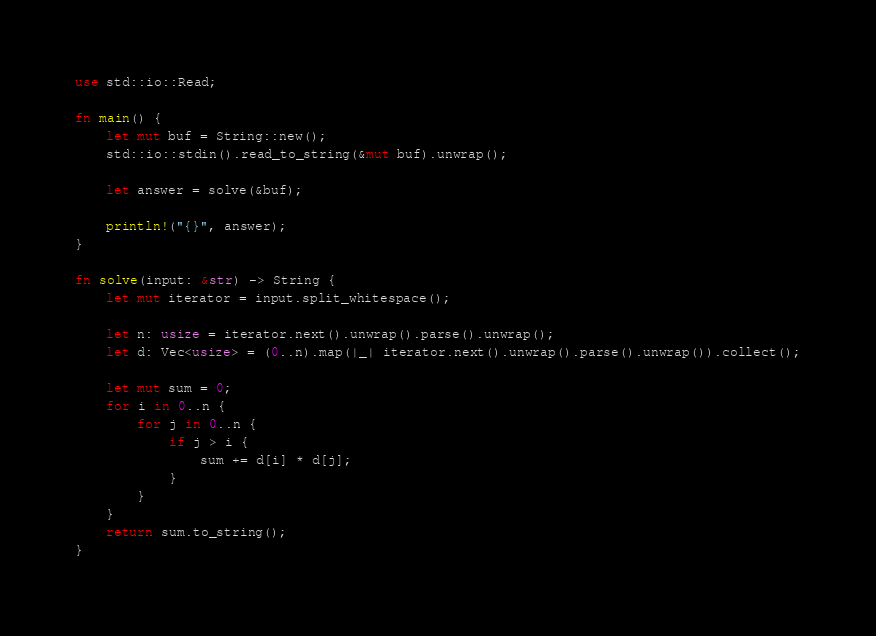Convert code to text. <code><loc_0><loc_0><loc_500><loc_500><_Rust_>use std::io::Read;

fn main() {
    let mut buf = String::new();
    std::io::stdin().read_to_string(&mut buf).unwrap();

    let answer = solve(&buf);

    println!("{}", answer);
}

fn solve(input: &str) -> String {
    let mut iterator = input.split_whitespace();

    let n: usize = iterator.next().unwrap().parse().unwrap();
    let d: Vec<usize> = (0..n).map(|_| iterator.next().unwrap().parse().unwrap()).collect();

    let mut sum = 0;
    for i in 0..n {
        for j in 0..n {
            if j > i {
                sum += d[i] * d[j];
            }
        }
    }
    return sum.to_string();
}
</code> 